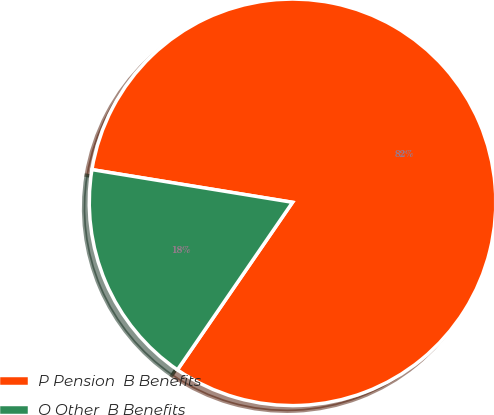Convert chart to OTSL. <chart><loc_0><loc_0><loc_500><loc_500><pie_chart><fcel>P Pension  B Benefits<fcel>O Other  B Benefits<nl><fcel>82.01%<fcel>17.99%<nl></chart> 